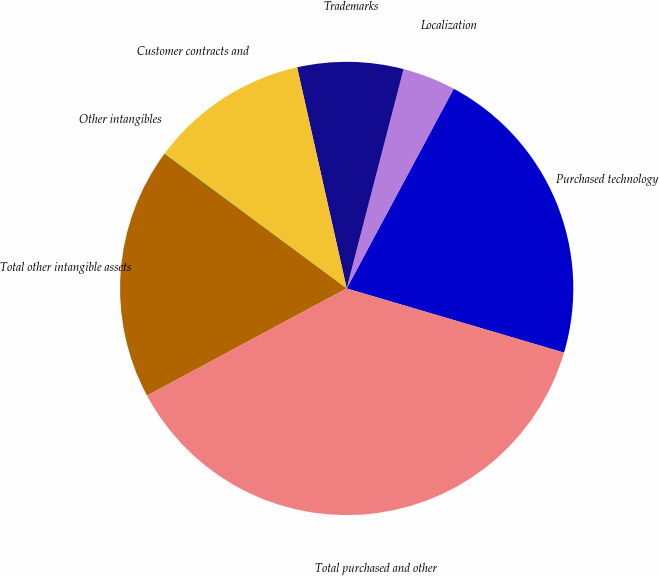Convert chart. <chart><loc_0><loc_0><loc_500><loc_500><pie_chart><fcel>Purchased technology<fcel>Localization<fcel>Trademarks<fcel>Customer contracts and<fcel>Other intangibles<fcel>Total other intangible assets<fcel>Total purchased and other<nl><fcel>21.74%<fcel>3.79%<fcel>7.55%<fcel>11.31%<fcel>0.04%<fcel>17.98%<fcel>37.59%<nl></chart> 